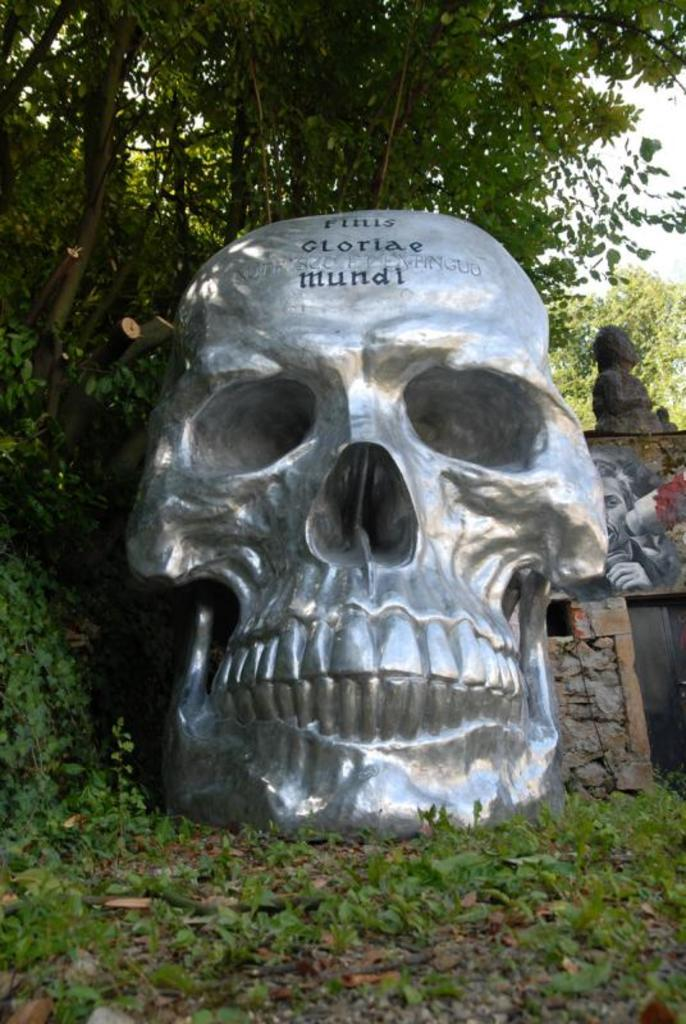What is the main subject of the image in the foreground of the picture? There is a skull sculpture in the image. Where is the skull sculpture located? The skull sculpture is on the grass. What can be seen in the background of the image? There is a photo frame and a statue in the background of the image, along with trees. What type of treatment is being administered to the bushes in the image? There are no bushes present in the image, so no treatment is being administered. 